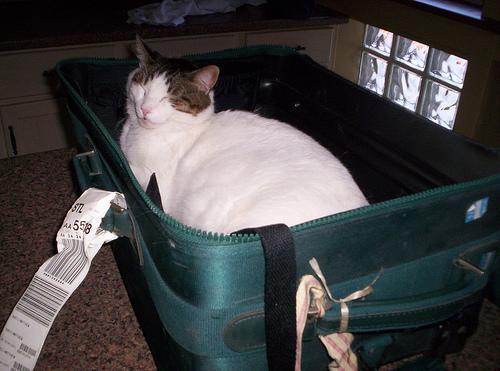How many cats are in the suitcase?
Give a very brief answer. 1. 